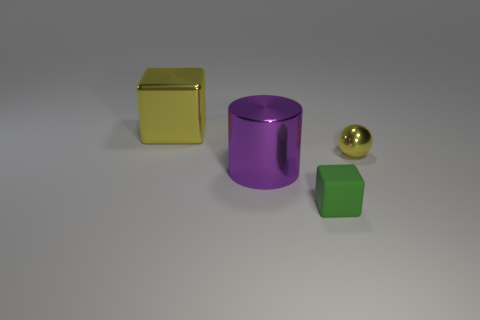Add 3 small green things. How many objects exist? 7 Subtract all yellow blocks. How many blocks are left? 1 Subtract 0 brown balls. How many objects are left? 4 Subtract all spheres. How many objects are left? 3 Subtract all blue balls. Subtract all gray blocks. How many balls are left? 1 Subtract all tiny matte blocks. Subtract all green blocks. How many objects are left? 2 Add 2 big shiny things. How many big shiny things are left? 4 Add 3 small red metal cubes. How many small red metal cubes exist? 3 